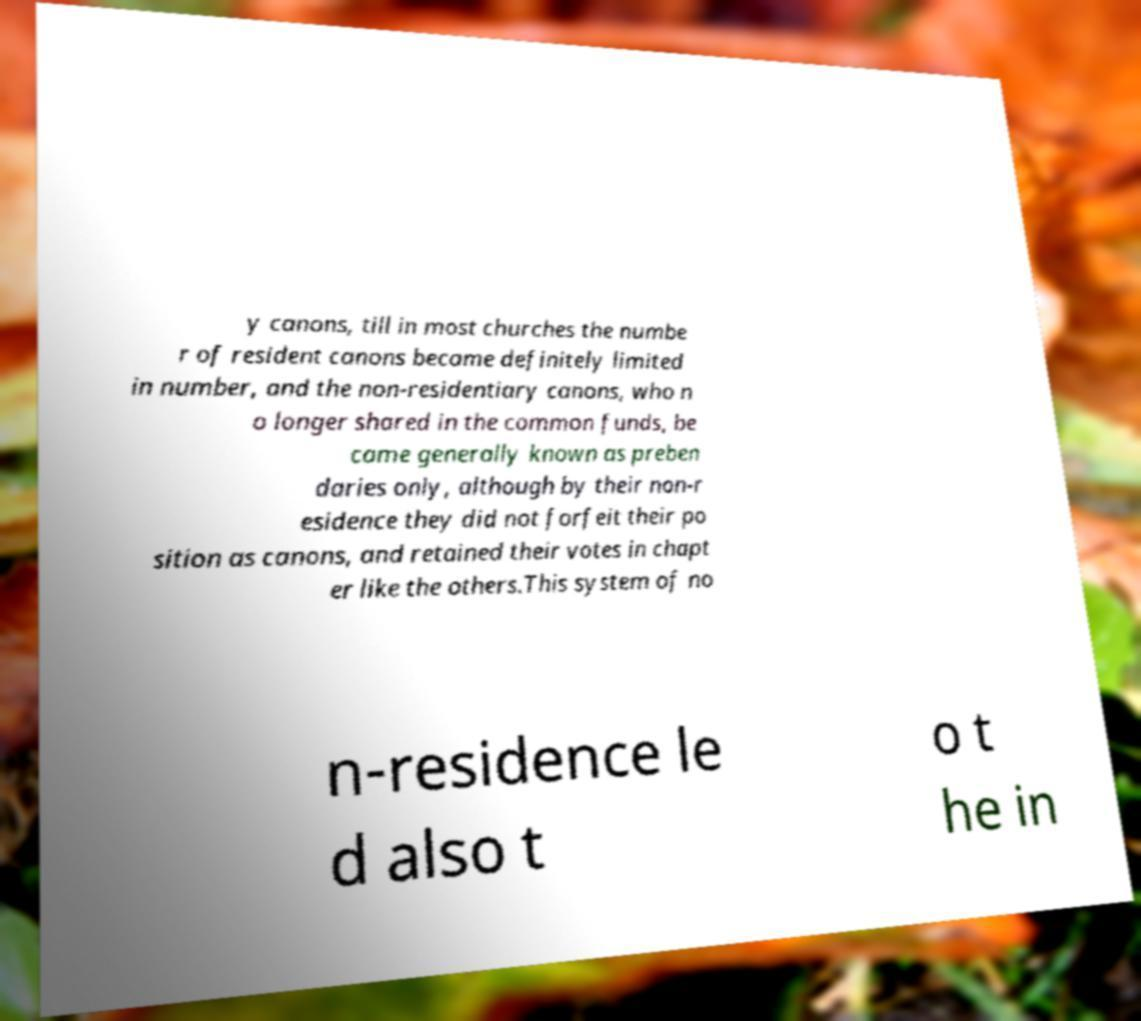There's text embedded in this image that I need extracted. Can you transcribe it verbatim? y canons, till in most churches the numbe r of resident canons became definitely limited in number, and the non-residentiary canons, who n o longer shared in the common funds, be came generally known as preben daries only, although by their non-r esidence they did not forfeit their po sition as canons, and retained their votes in chapt er like the others.This system of no n-residence le d also t o t he in 